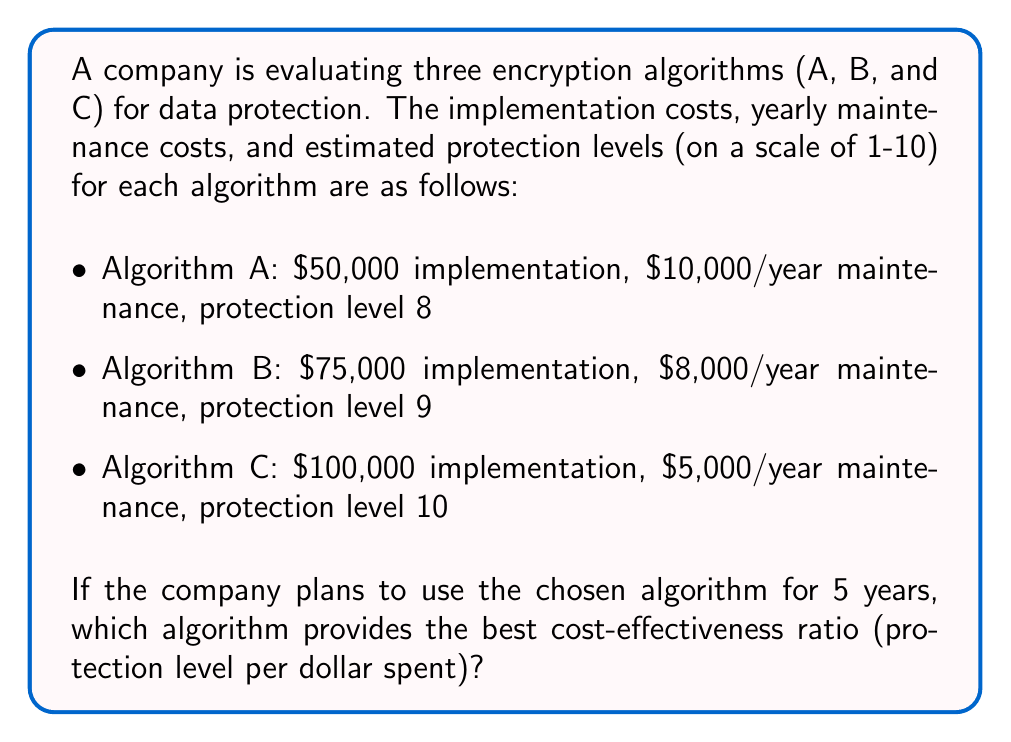Teach me how to tackle this problem. To determine the most cost-effective algorithm, we need to calculate the total cost for each algorithm over 5 years and then compare the protection level per dollar spent.

1. Calculate total cost for each algorithm over 5 years:

Algorithm A: 
$$ \text{Total Cost}_A = 50,000 + (10,000 \times 5) = \$100,000 $$

Algorithm B:
$$ \text{Total Cost}_B = 75,000 + (8,000 \times 5) = \$115,000 $$

Algorithm C:
$$ \text{Total Cost}_C = 100,000 + (5,000 \times 5) = \$125,000 $$

2. Calculate the cost-effectiveness ratio (protection level per dollar spent) for each algorithm:

Algorithm A:
$$ \text{Ratio}_A = \frac{\text{Protection Level}}{\text{Total Cost}} = \frac{8}{100,000} = 0.00008 $$

Algorithm B:
$$ \text{Ratio}_B = \frac{\text{Protection Level}}{\text{Total Cost}} = \frac{9}{115,000} \approx 0.00007826 $$

Algorithm C:
$$ \text{Ratio}_C = \frac{\text{Protection Level}}{\text{Total Cost}} = \frac{10}{125,000} = 0.00008 $$

3. Compare the ratios:

Algorithm A: 0.00008
Algorithm B: 0.00007826
Algorithm C: 0.00008

Algorithms A and C have the highest and equal cost-effectiveness ratios.
Answer: Algorithms A and C (tie) 